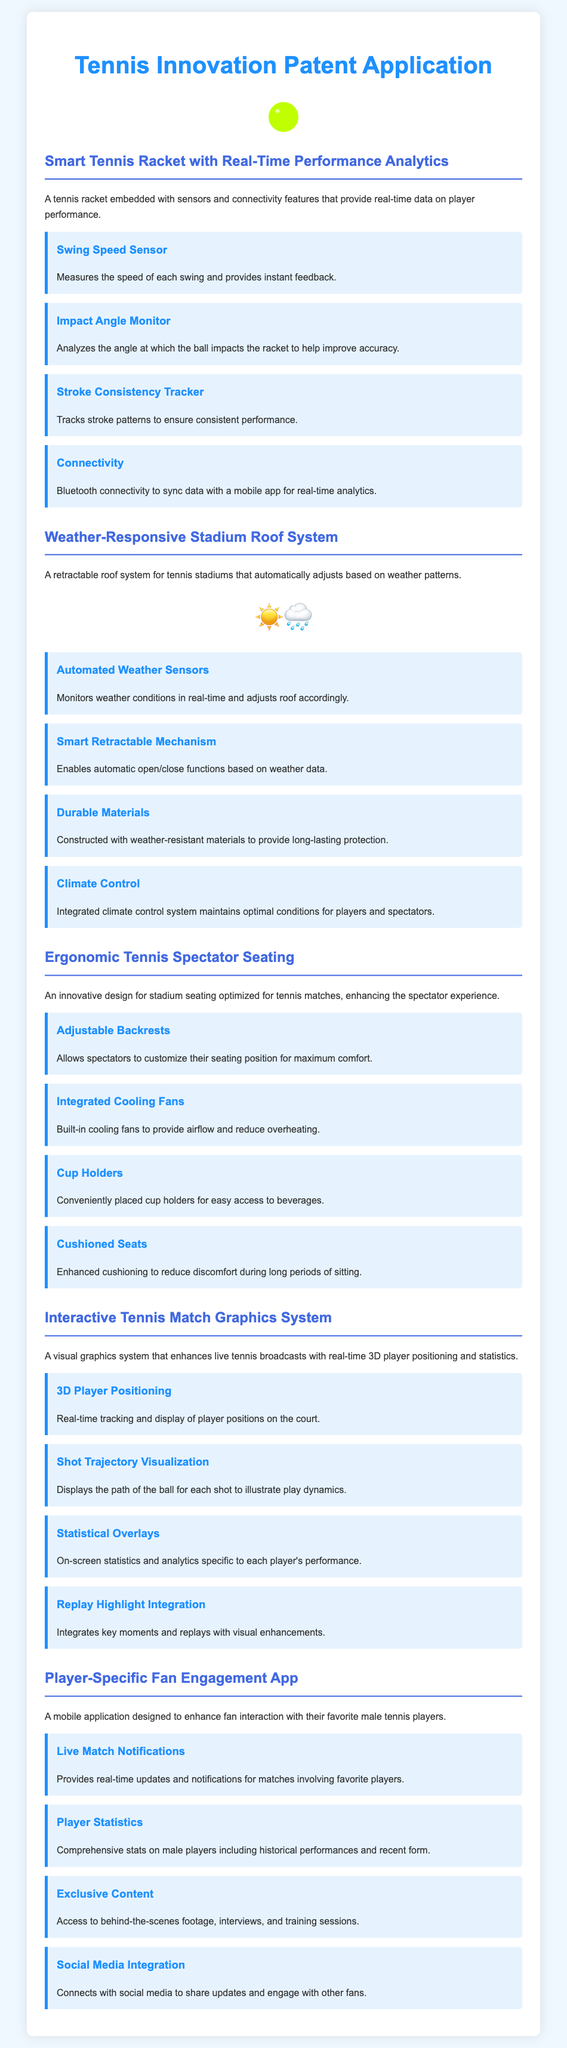What is the main purpose of the Smart Tennis Racket? The main purpose is to provide real-time data on player performance through embedded sensors and connectivity features.
Answer: Real-time data on player performance What feature measures the speed of each swing? This feature is identified as the Swing Speed Sensor.
Answer: Swing Speed Sensor What conditions does the Weather-Responsive Stadium Roof System monitor? It monitors weather conditions in real-time to adjust the roof accordingly.
Answer: Weather conditions Which feature in spectator seating provides airflow? The Integrated Cooling Fans provide airflow to reduce overheating.
Answer: Integrated Cooling Fans How does the Interactive Tennis Match Graphics System display player positions? It uses real-time tracking to show 3D player positioning on the court.
Answer: 3D player positioning What kind of content does the Player-Specific Fan Engagement App offer? It offers exclusive behind-the-scenes footage, interviews, and training sessions.
Answer: Exclusive content What mechanism allows the stadium roof to automatically adjust? The Smart Retractable Mechanism enables this automatic adjustment based on weather data.
Answer: Smart Retractable Mechanism What type of fans is the ergonomic seating designed for? The seating is optimized for tennis matches, enhancing the spectator experience.
Answer: Tennis matches 